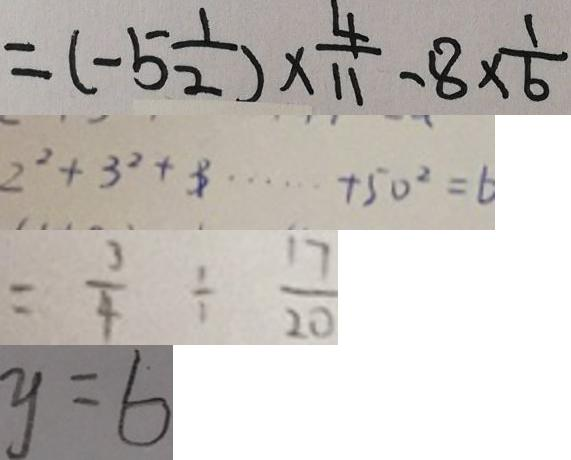Convert formula to latex. <formula><loc_0><loc_0><loc_500><loc_500>= ( - 5 \frac { 1 } { 2 } ) \times \frac { 4 } { 1 1 } - 8 \times \frac { 1 } { 6 } 
 2 ^ { 2 } + 3 ^ { 2 } + 3 \cdots + 5 0 ^ { 2 } = 6 
 = \frac { 3 } { 4 } \div \frac { 1 7 } { 2 0 } 
 y = 6</formula> 